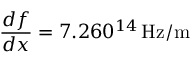<formula> <loc_0><loc_0><loc_500><loc_500>\frac { d f } { d x } = 7 . 2 6 \ t i m e 1 0 ^ { 1 4 } \, H z / m</formula> 